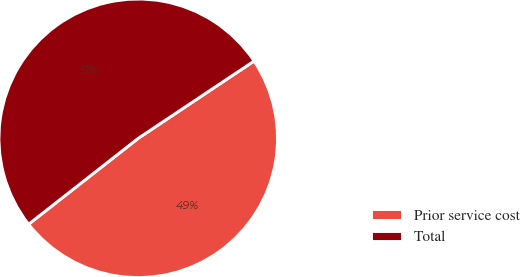Convert chart. <chart><loc_0><loc_0><loc_500><loc_500><pie_chart><fcel>Prior service cost<fcel>Total<nl><fcel>48.78%<fcel>51.22%<nl></chart> 